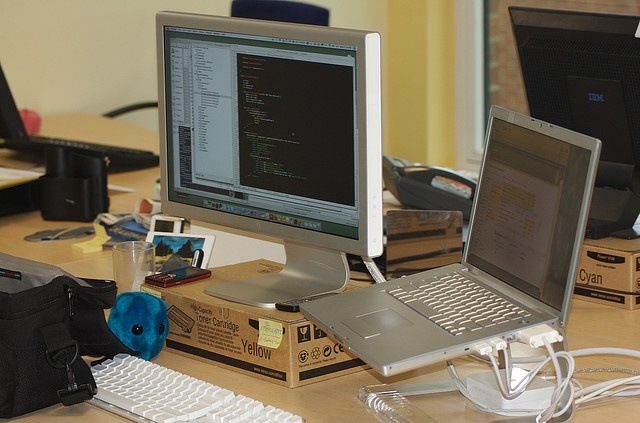Describe the objects in this image and their specific colors. I can see tv in tan, black, and gray tones, laptop in tan, gray, and black tones, backpack in tan, black, and gray tones, keyboard in tan, lightgray, and darkgray tones, and keyboard in tan, gray, and darkgray tones in this image. 